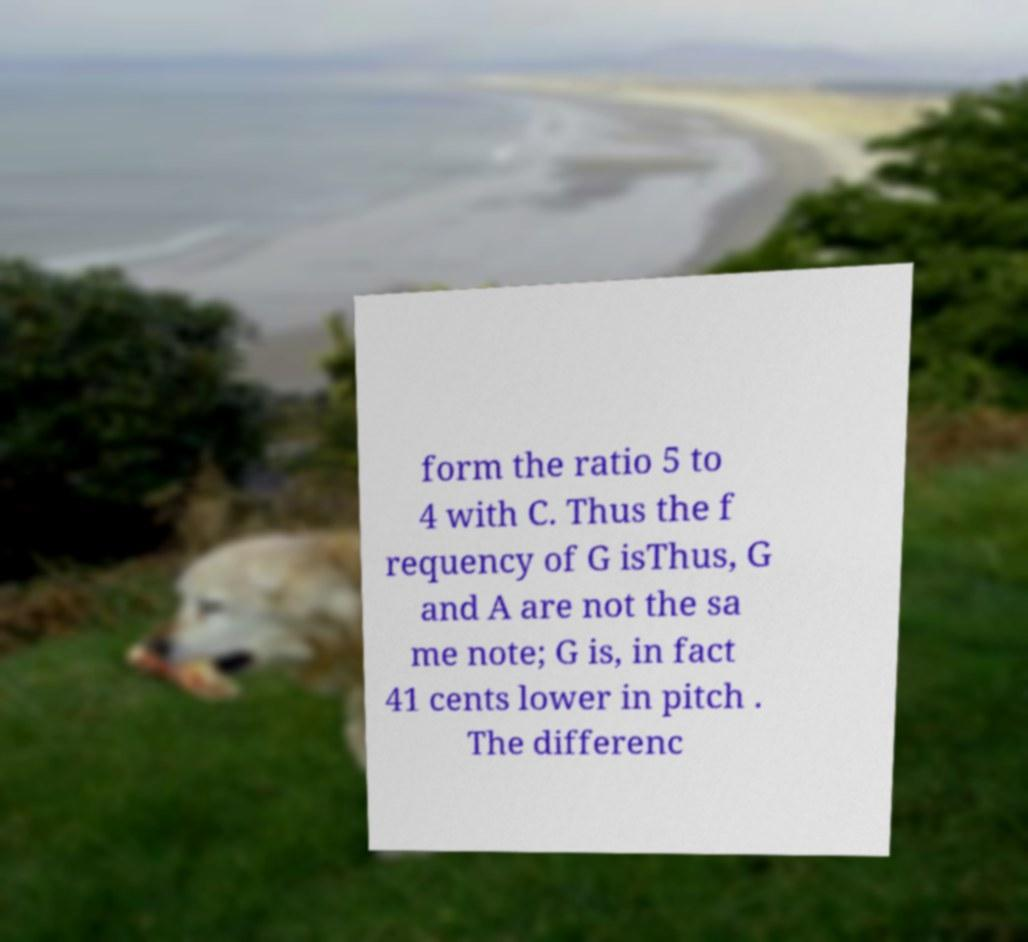What messages or text are displayed in this image? I need them in a readable, typed format. form the ratio 5 to 4 with C. Thus the f requency of G isThus, G and A are not the sa me note; G is, in fact 41 cents lower in pitch . The differenc 